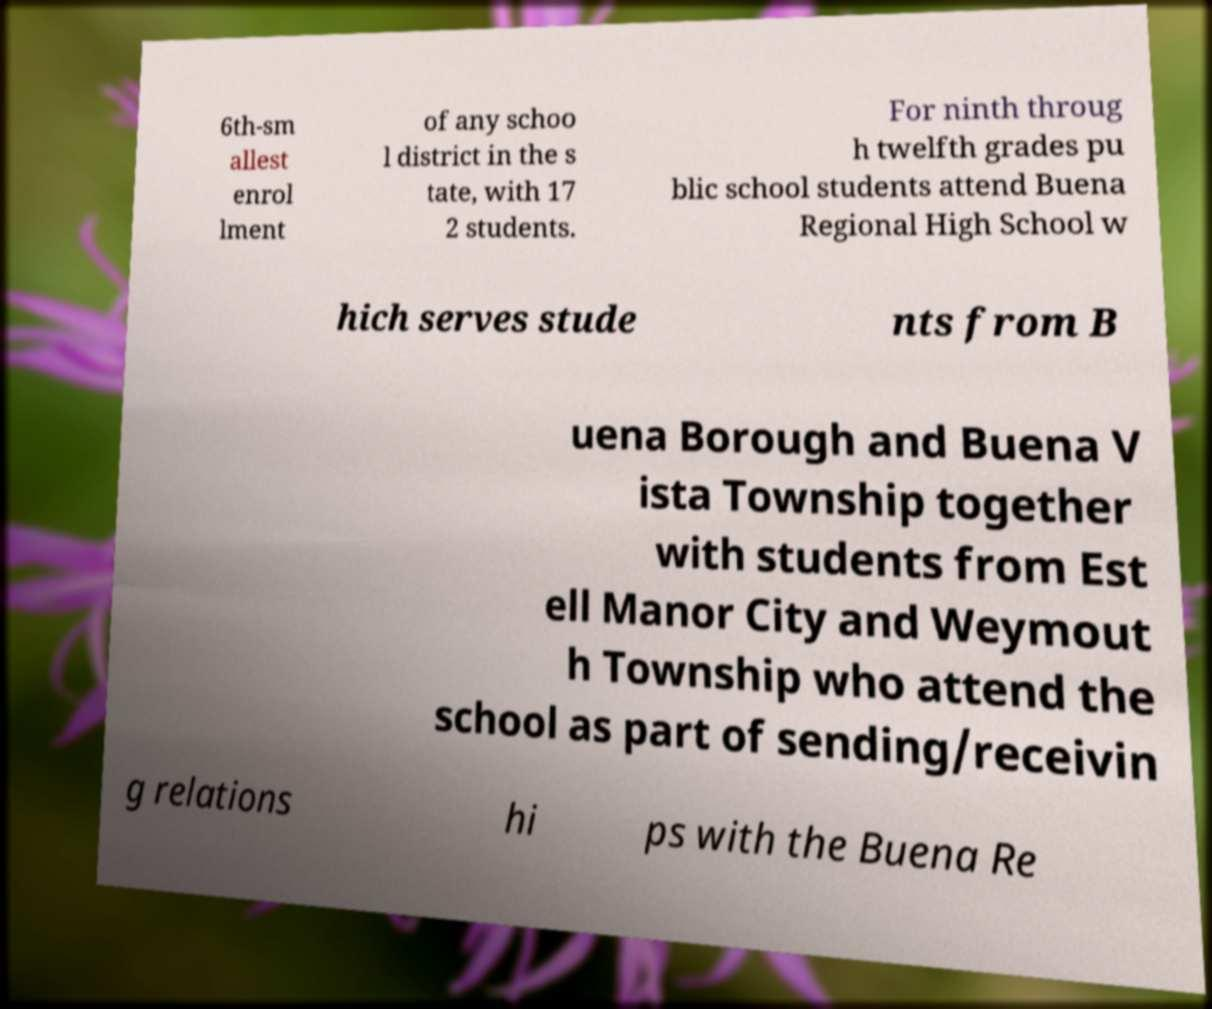What messages or text are displayed in this image? I need them in a readable, typed format. 6th-sm allest enrol lment of any schoo l district in the s tate, with 17 2 students. For ninth throug h twelfth grades pu blic school students attend Buena Regional High School w hich serves stude nts from B uena Borough and Buena V ista Township together with students from Est ell Manor City and Weymout h Township who attend the school as part of sending/receivin g relations hi ps with the Buena Re 